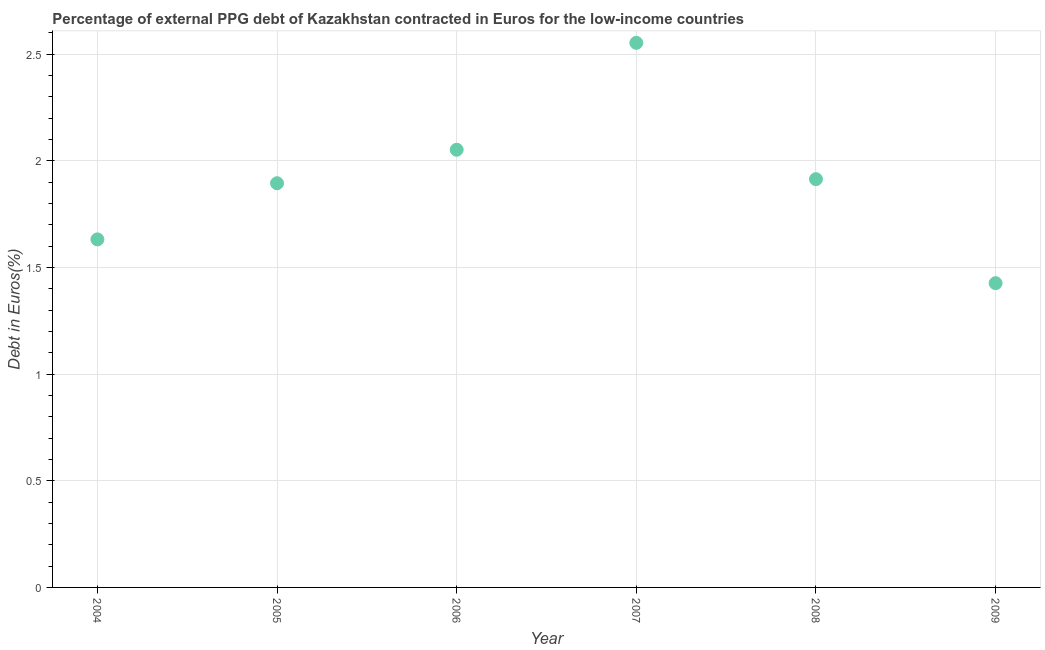What is the currency composition of ppg debt in 2004?
Give a very brief answer. 1.63. Across all years, what is the maximum currency composition of ppg debt?
Your answer should be very brief. 2.55. Across all years, what is the minimum currency composition of ppg debt?
Give a very brief answer. 1.43. What is the sum of the currency composition of ppg debt?
Keep it short and to the point. 11.47. What is the difference between the currency composition of ppg debt in 2004 and 2008?
Your answer should be very brief. -0.28. What is the average currency composition of ppg debt per year?
Offer a terse response. 1.91. What is the median currency composition of ppg debt?
Your answer should be very brief. 1.9. What is the ratio of the currency composition of ppg debt in 2004 to that in 2008?
Your answer should be compact. 0.85. Is the currency composition of ppg debt in 2006 less than that in 2008?
Provide a succinct answer. No. Is the difference between the currency composition of ppg debt in 2005 and 2007 greater than the difference between any two years?
Provide a succinct answer. No. What is the difference between the highest and the second highest currency composition of ppg debt?
Your response must be concise. 0.5. What is the difference between the highest and the lowest currency composition of ppg debt?
Offer a very short reply. 1.13. Does the currency composition of ppg debt monotonically increase over the years?
Make the answer very short. No. How many dotlines are there?
Your response must be concise. 1. What is the difference between two consecutive major ticks on the Y-axis?
Provide a short and direct response. 0.5. Does the graph contain any zero values?
Give a very brief answer. No. What is the title of the graph?
Your response must be concise. Percentage of external PPG debt of Kazakhstan contracted in Euros for the low-income countries. What is the label or title of the X-axis?
Your answer should be very brief. Year. What is the label or title of the Y-axis?
Your answer should be very brief. Debt in Euros(%). What is the Debt in Euros(%) in 2004?
Keep it short and to the point. 1.63. What is the Debt in Euros(%) in 2005?
Keep it short and to the point. 1.89. What is the Debt in Euros(%) in 2006?
Keep it short and to the point. 2.05. What is the Debt in Euros(%) in 2007?
Ensure brevity in your answer.  2.55. What is the Debt in Euros(%) in 2008?
Provide a short and direct response. 1.91. What is the Debt in Euros(%) in 2009?
Your answer should be very brief. 1.43. What is the difference between the Debt in Euros(%) in 2004 and 2005?
Offer a very short reply. -0.26. What is the difference between the Debt in Euros(%) in 2004 and 2006?
Your answer should be compact. -0.42. What is the difference between the Debt in Euros(%) in 2004 and 2007?
Your response must be concise. -0.92. What is the difference between the Debt in Euros(%) in 2004 and 2008?
Ensure brevity in your answer.  -0.28. What is the difference between the Debt in Euros(%) in 2004 and 2009?
Provide a short and direct response. 0.21. What is the difference between the Debt in Euros(%) in 2005 and 2006?
Offer a terse response. -0.16. What is the difference between the Debt in Euros(%) in 2005 and 2007?
Keep it short and to the point. -0.66. What is the difference between the Debt in Euros(%) in 2005 and 2008?
Make the answer very short. -0.02. What is the difference between the Debt in Euros(%) in 2005 and 2009?
Provide a short and direct response. 0.47. What is the difference between the Debt in Euros(%) in 2006 and 2007?
Give a very brief answer. -0.5. What is the difference between the Debt in Euros(%) in 2006 and 2008?
Keep it short and to the point. 0.14. What is the difference between the Debt in Euros(%) in 2006 and 2009?
Your answer should be compact. 0.63. What is the difference between the Debt in Euros(%) in 2007 and 2008?
Make the answer very short. 0.64. What is the difference between the Debt in Euros(%) in 2007 and 2009?
Offer a terse response. 1.13. What is the difference between the Debt in Euros(%) in 2008 and 2009?
Keep it short and to the point. 0.49. What is the ratio of the Debt in Euros(%) in 2004 to that in 2005?
Your answer should be very brief. 0.86. What is the ratio of the Debt in Euros(%) in 2004 to that in 2006?
Offer a very short reply. 0.8. What is the ratio of the Debt in Euros(%) in 2004 to that in 2007?
Provide a succinct answer. 0.64. What is the ratio of the Debt in Euros(%) in 2004 to that in 2008?
Provide a short and direct response. 0.85. What is the ratio of the Debt in Euros(%) in 2004 to that in 2009?
Ensure brevity in your answer.  1.14. What is the ratio of the Debt in Euros(%) in 2005 to that in 2006?
Provide a short and direct response. 0.92. What is the ratio of the Debt in Euros(%) in 2005 to that in 2007?
Your answer should be very brief. 0.74. What is the ratio of the Debt in Euros(%) in 2005 to that in 2009?
Keep it short and to the point. 1.33. What is the ratio of the Debt in Euros(%) in 2006 to that in 2007?
Give a very brief answer. 0.8. What is the ratio of the Debt in Euros(%) in 2006 to that in 2008?
Offer a terse response. 1.07. What is the ratio of the Debt in Euros(%) in 2006 to that in 2009?
Provide a succinct answer. 1.44. What is the ratio of the Debt in Euros(%) in 2007 to that in 2008?
Offer a very short reply. 1.33. What is the ratio of the Debt in Euros(%) in 2007 to that in 2009?
Ensure brevity in your answer.  1.79. What is the ratio of the Debt in Euros(%) in 2008 to that in 2009?
Provide a succinct answer. 1.34. 